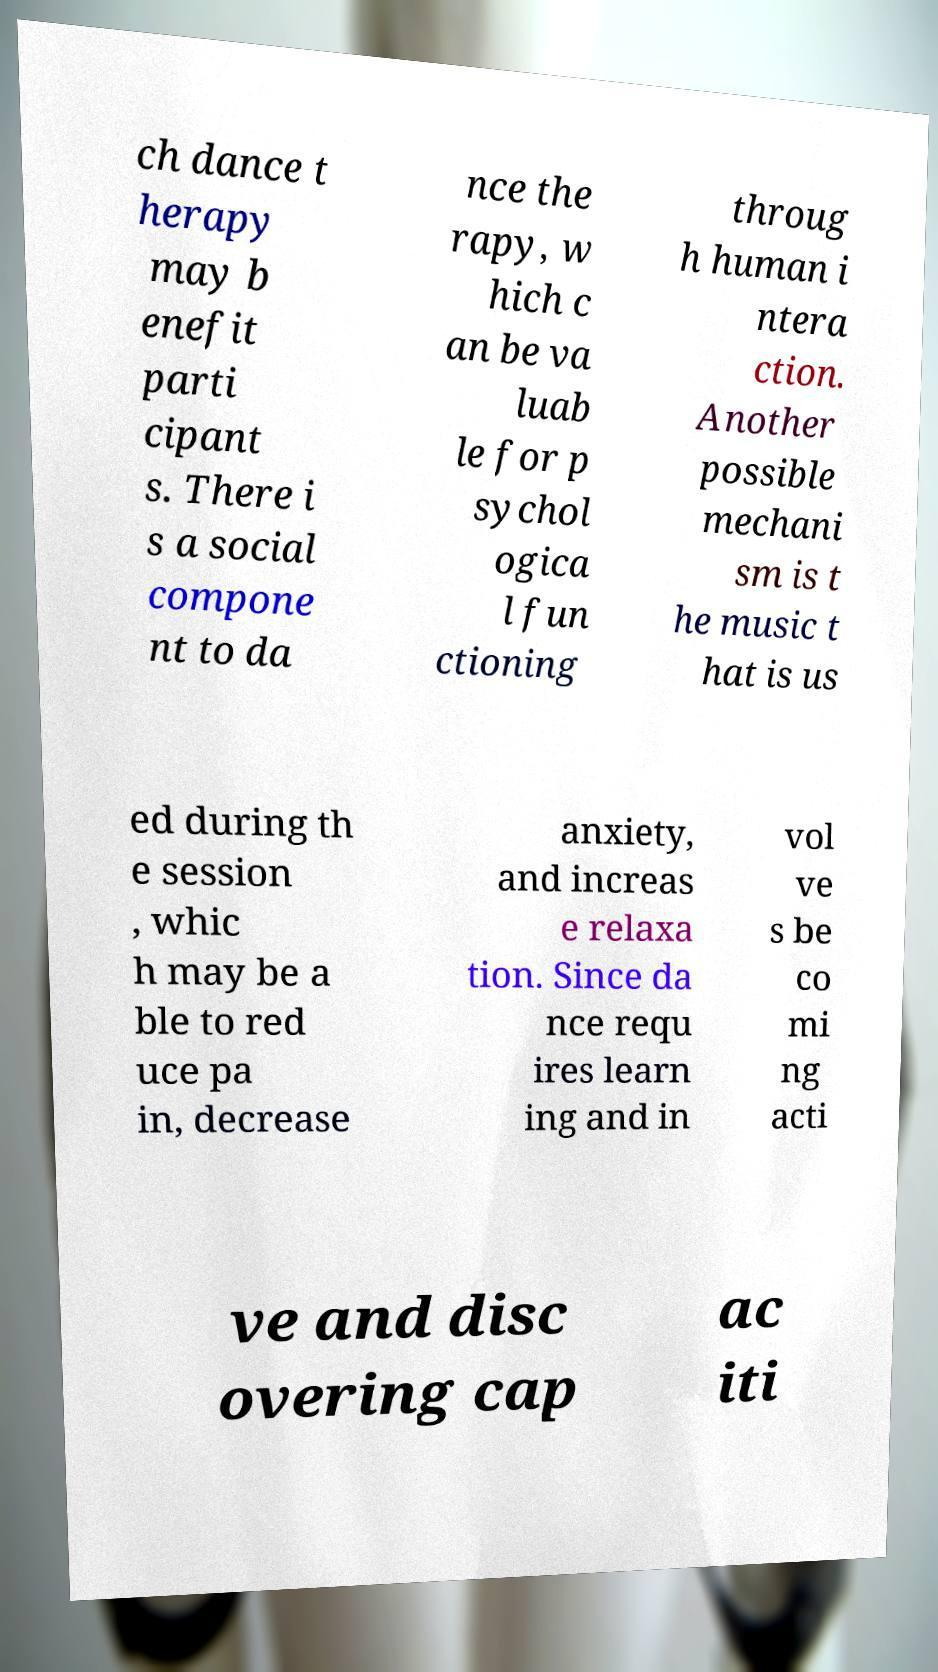Can you read and provide the text displayed in the image?This photo seems to have some interesting text. Can you extract and type it out for me? ch dance t herapy may b enefit parti cipant s. There i s a social compone nt to da nce the rapy, w hich c an be va luab le for p sychol ogica l fun ctioning throug h human i ntera ction. Another possible mechani sm is t he music t hat is us ed during th e session , whic h may be a ble to red uce pa in, decrease anxiety, and increas e relaxa tion. Since da nce requ ires learn ing and in vol ve s be co mi ng acti ve and disc overing cap ac iti 